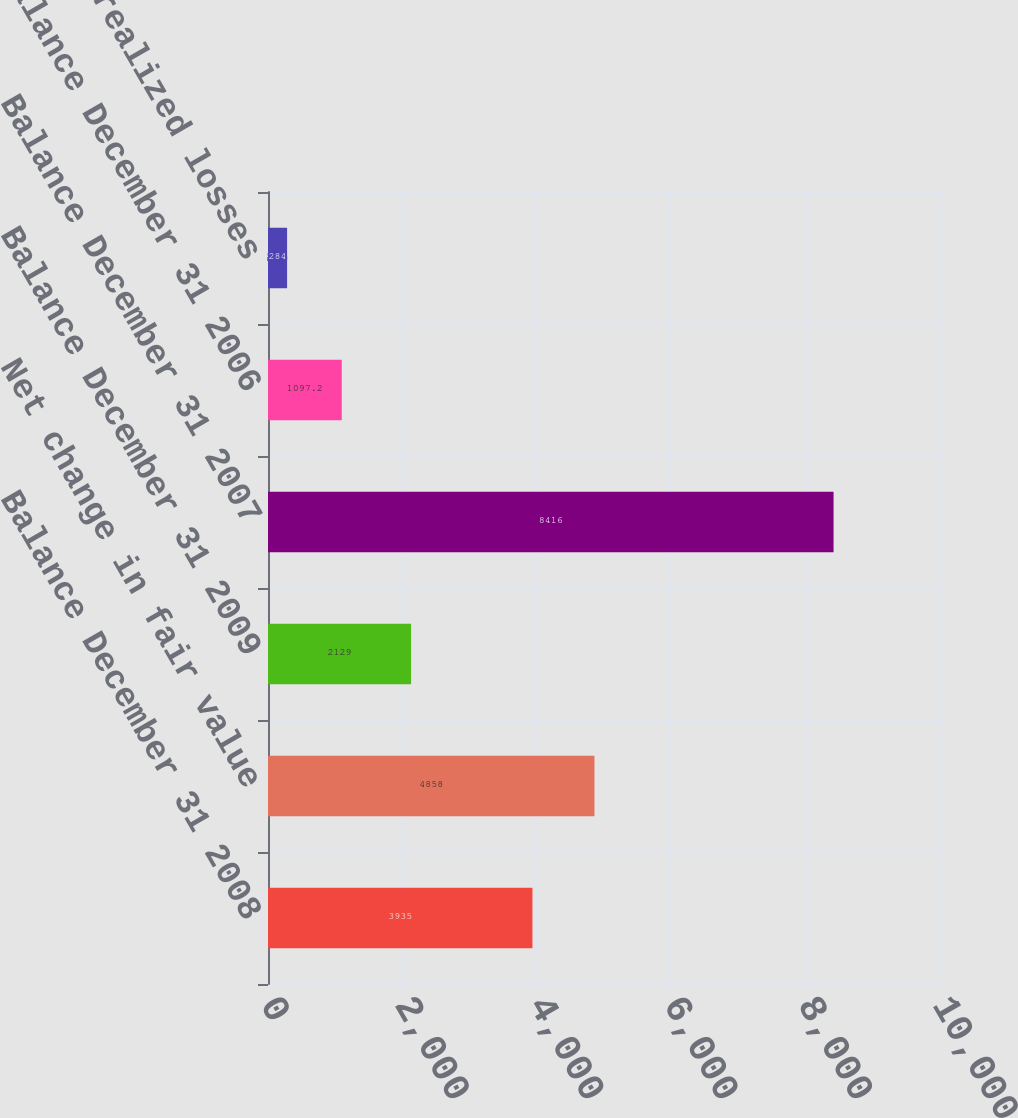<chart> <loc_0><loc_0><loc_500><loc_500><bar_chart><fcel>Balance December 31 2008<fcel>Net change in fair value<fcel>Balance December 31 2009<fcel>Balance December 31 2007<fcel>Balance December 31 2006<fcel>Net realized losses<nl><fcel>3935<fcel>4858<fcel>2129<fcel>8416<fcel>1097.2<fcel>284<nl></chart> 